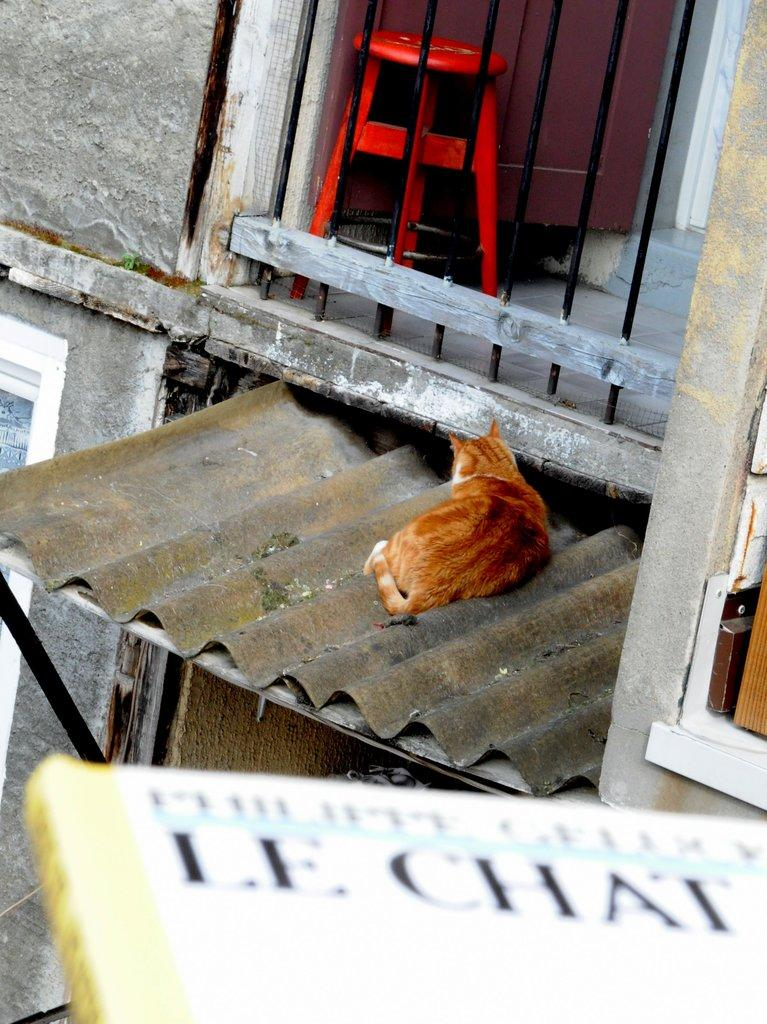What is the main structure in the image? There is a building in the image. Can you describe the animal sitting on the building? A cat is sitting on the roof of the building. What object is near the railing of the building? There is a stool near the railing. What is written or depicted at the bottom of the image? There is a board with text at the bottom of the image. How much shade does the baby provide in the image? There is no baby present in the image, so it cannot provide any shade. 